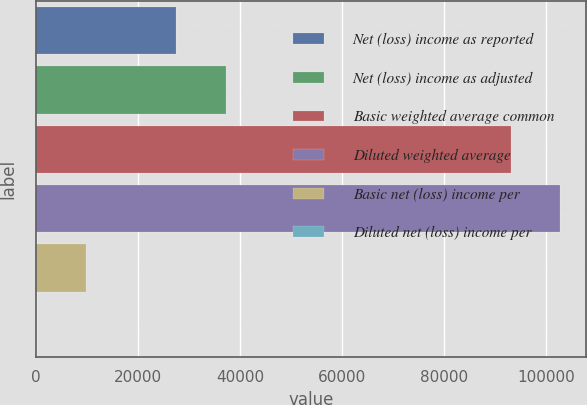Convert chart to OTSL. <chart><loc_0><loc_0><loc_500><loc_500><bar_chart><fcel>Net (loss) income as reported<fcel>Net (loss) income as adjusted<fcel>Basic weighted average common<fcel>Diluted weighted average<fcel>Basic net (loss) income per<fcel>Diluted net (loss) income per<nl><fcel>27423<fcel>37147<fcel>93025<fcel>102749<fcel>9724.25<fcel>0.28<nl></chart> 